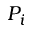<formula> <loc_0><loc_0><loc_500><loc_500>P _ { i }</formula> 